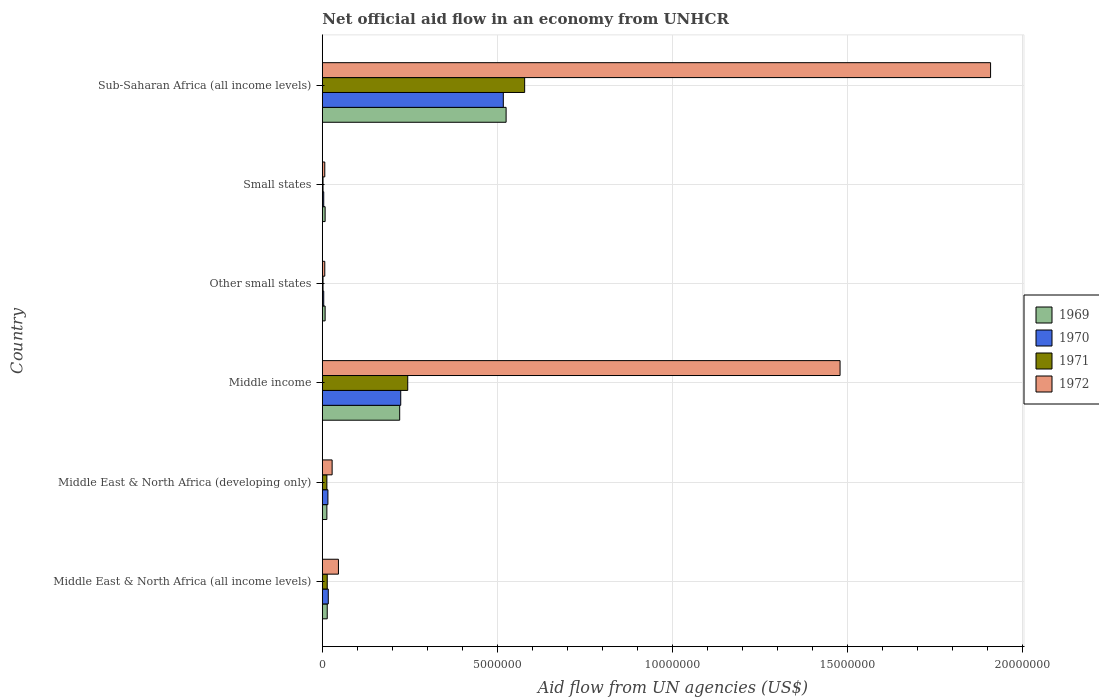How many different coloured bars are there?
Make the answer very short. 4. How many groups of bars are there?
Keep it short and to the point. 6. Are the number of bars per tick equal to the number of legend labels?
Ensure brevity in your answer.  Yes. Are the number of bars on each tick of the Y-axis equal?
Provide a succinct answer. Yes. How many bars are there on the 3rd tick from the top?
Your answer should be compact. 4. How many bars are there on the 2nd tick from the bottom?
Your answer should be very brief. 4. What is the label of the 3rd group of bars from the top?
Make the answer very short. Other small states. In how many cases, is the number of bars for a given country not equal to the number of legend labels?
Ensure brevity in your answer.  0. Across all countries, what is the maximum net official aid flow in 1970?
Provide a succinct answer. 5.17e+06. In which country was the net official aid flow in 1969 maximum?
Your answer should be compact. Sub-Saharan Africa (all income levels). In which country was the net official aid flow in 1970 minimum?
Keep it short and to the point. Other small states. What is the total net official aid flow in 1969 in the graph?
Offer a terse response. 7.89e+06. What is the difference between the net official aid flow in 1969 in Other small states and that in Sub-Saharan Africa (all income levels)?
Offer a very short reply. -5.17e+06. What is the difference between the net official aid flow in 1969 in Sub-Saharan Africa (all income levels) and the net official aid flow in 1971 in Middle income?
Offer a very short reply. 2.81e+06. What is the average net official aid flow in 1969 per country?
Ensure brevity in your answer.  1.32e+06. What is the difference between the net official aid flow in 1971 and net official aid flow in 1970 in Middle East & North Africa (developing only)?
Provide a short and direct response. -3.00e+04. What is the ratio of the net official aid flow in 1972 in Middle income to that in Other small states?
Offer a very short reply. 211.29. What is the difference between the highest and the second highest net official aid flow in 1970?
Your answer should be very brief. 2.93e+06. What is the difference between the highest and the lowest net official aid flow in 1972?
Keep it short and to the point. 1.90e+07. In how many countries, is the net official aid flow in 1971 greater than the average net official aid flow in 1971 taken over all countries?
Your answer should be very brief. 2. Is the sum of the net official aid flow in 1972 in Middle East & North Africa (developing only) and Middle income greater than the maximum net official aid flow in 1970 across all countries?
Provide a short and direct response. Yes. Is it the case that in every country, the sum of the net official aid flow in 1969 and net official aid flow in 1970 is greater than the sum of net official aid flow in 1972 and net official aid flow in 1971?
Offer a terse response. No. Is it the case that in every country, the sum of the net official aid flow in 1971 and net official aid flow in 1969 is greater than the net official aid flow in 1970?
Provide a succinct answer. Yes. What is the difference between two consecutive major ticks on the X-axis?
Keep it short and to the point. 5.00e+06. Where does the legend appear in the graph?
Keep it short and to the point. Center right. What is the title of the graph?
Your answer should be very brief. Net official aid flow in an economy from UNHCR. Does "1964" appear as one of the legend labels in the graph?
Provide a short and direct response. No. What is the label or title of the X-axis?
Provide a succinct answer. Aid flow from UN agencies (US$). What is the Aid flow from UN agencies (US$) of 1970 in Middle East & North Africa (all income levels)?
Provide a succinct answer. 1.70e+05. What is the Aid flow from UN agencies (US$) of 1972 in Middle East & North Africa (all income levels)?
Keep it short and to the point. 4.60e+05. What is the Aid flow from UN agencies (US$) of 1969 in Middle East & North Africa (developing only)?
Your answer should be compact. 1.30e+05. What is the Aid flow from UN agencies (US$) in 1972 in Middle East & North Africa (developing only)?
Your response must be concise. 2.80e+05. What is the Aid flow from UN agencies (US$) of 1969 in Middle income?
Provide a succinct answer. 2.21e+06. What is the Aid flow from UN agencies (US$) of 1970 in Middle income?
Ensure brevity in your answer.  2.24e+06. What is the Aid flow from UN agencies (US$) of 1971 in Middle income?
Your answer should be compact. 2.44e+06. What is the Aid flow from UN agencies (US$) in 1972 in Middle income?
Offer a very short reply. 1.48e+07. What is the Aid flow from UN agencies (US$) of 1969 in Other small states?
Make the answer very short. 8.00e+04. What is the Aid flow from UN agencies (US$) in 1970 in Other small states?
Your answer should be compact. 4.00e+04. What is the Aid flow from UN agencies (US$) in 1970 in Small states?
Provide a short and direct response. 4.00e+04. What is the Aid flow from UN agencies (US$) in 1969 in Sub-Saharan Africa (all income levels)?
Your answer should be compact. 5.25e+06. What is the Aid flow from UN agencies (US$) of 1970 in Sub-Saharan Africa (all income levels)?
Your response must be concise. 5.17e+06. What is the Aid flow from UN agencies (US$) of 1971 in Sub-Saharan Africa (all income levels)?
Ensure brevity in your answer.  5.78e+06. What is the Aid flow from UN agencies (US$) of 1972 in Sub-Saharan Africa (all income levels)?
Your response must be concise. 1.91e+07. Across all countries, what is the maximum Aid flow from UN agencies (US$) of 1969?
Your answer should be very brief. 5.25e+06. Across all countries, what is the maximum Aid flow from UN agencies (US$) in 1970?
Give a very brief answer. 5.17e+06. Across all countries, what is the maximum Aid flow from UN agencies (US$) in 1971?
Your response must be concise. 5.78e+06. Across all countries, what is the maximum Aid flow from UN agencies (US$) in 1972?
Your answer should be compact. 1.91e+07. Across all countries, what is the minimum Aid flow from UN agencies (US$) in 1970?
Keep it short and to the point. 4.00e+04. Across all countries, what is the minimum Aid flow from UN agencies (US$) in 1971?
Make the answer very short. 2.00e+04. What is the total Aid flow from UN agencies (US$) of 1969 in the graph?
Provide a succinct answer. 7.89e+06. What is the total Aid flow from UN agencies (US$) in 1970 in the graph?
Give a very brief answer. 7.82e+06. What is the total Aid flow from UN agencies (US$) of 1971 in the graph?
Your answer should be compact. 8.53e+06. What is the total Aid flow from UN agencies (US$) of 1972 in the graph?
Offer a terse response. 3.48e+07. What is the difference between the Aid flow from UN agencies (US$) in 1969 in Middle East & North Africa (all income levels) and that in Middle East & North Africa (developing only)?
Make the answer very short. 10000. What is the difference between the Aid flow from UN agencies (US$) of 1970 in Middle East & North Africa (all income levels) and that in Middle East & North Africa (developing only)?
Keep it short and to the point. 10000. What is the difference between the Aid flow from UN agencies (US$) in 1969 in Middle East & North Africa (all income levels) and that in Middle income?
Your response must be concise. -2.07e+06. What is the difference between the Aid flow from UN agencies (US$) of 1970 in Middle East & North Africa (all income levels) and that in Middle income?
Offer a terse response. -2.07e+06. What is the difference between the Aid flow from UN agencies (US$) in 1971 in Middle East & North Africa (all income levels) and that in Middle income?
Provide a succinct answer. -2.30e+06. What is the difference between the Aid flow from UN agencies (US$) in 1972 in Middle East & North Africa (all income levels) and that in Middle income?
Your answer should be very brief. -1.43e+07. What is the difference between the Aid flow from UN agencies (US$) in 1971 in Middle East & North Africa (all income levels) and that in Other small states?
Give a very brief answer. 1.20e+05. What is the difference between the Aid flow from UN agencies (US$) in 1972 in Middle East & North Africa (all income levels) and that in Other small states?
Make the answer very short. 3.90e+05. What is the difference between the Aid flow from UN agencies (US$) in 1969 in Middle East & North Africa (all income levels) and that in Small states?
Ensure brevity in your answer.  6.00e+04. What is the difference between the Aid flow from UN agencies (US$) of 1972 in Middle East & North Africa (all income levels) and that in Small states?
Give a very brief answer. 3.90e+05. What is the difference between the Aid flow from UN agencies (US$) of 1969 in Middle East & North Africa (all income levels) and that in Sub-Saharan Africa (all income levels)?
Offer a very short reply. -5.11e+06. What is the difference between the Aid flow from UN agencies (US$) of 1970 in Middle East & North Africa (all income levels) and that in Sub-Saharan Africa (all income levels)?
Ensure brevity in your answer.  -5.00e+06. What is the difference between the Aid flow from UN agencies (US$) of 1971 in Middle East & North Africa (all income levels) and that in Sub-Saharan Africa (all income levels)?
Your answer should be very brief. -5.64e+06. What is the difference between the Aid flow from UN agencies (US$) of 1972 in Middle East & North Africa (all income levels) and that in Sub-Saharan Africa (all income levels)?
Your answer should be very brief. -1.86e+07. What is the difference between the Aid flow from UN agencies (US$) of 1969 in Middle East & North Africa (developing only) and that in Middle income?
Your answer should be compact. -2.08e+06. What is the difference between the Aid flow from UN agencies (US$) of 1970 in Middle East & North Africa (developing only) and that in Middle income?
Give a very brief answer. -2.08e+06. What is the difference between the Aid flow from UN agencies (US$) of 1971 in Middle East & North Africa (developing only) and that in Middle income?
Give a very brief answer. -2.31e+06. What is the difference between the Aid flow from UN agencies (US$) in 1972 in Middle East & North Africa (developing only) and that in Middle income?
Offer a terse response. -1.45e+07. What is the difference between the Aid flow from UN agencies (US$) of 1969 in Middle East & North Africa (developing only) and that in Other small states?
Your response must be concise. 5.00e+04. What is the difference between the Aid flow from UN agencies (US$) of 1970 in Middle East & North Africa (developing only) and that in Other small states?
Keep it short and to the point. 1.20e+05. What is the difference between the Aid flow from UN agencies (US$) in 1971 in Middle East & North Africa (developing only) and that in Other small states?
Make the answer very short. 1.10e+05. What is the difference between the Aid flow from UN agencies (US$) in 1969 in Middle East & North Africa (developing only) and that in Sub-Saharan Africa (all income levels)?
Provide a succinct answer. -5.12e+06. What is the difference between the Aid flow from UN agencies (US$) in 1970 in Middle East & North Africa (developing only) and that in Sub-Saharan Africa (all income levels)?
Your answer should be very brief. -5.01e+06. What is the difference between the Aid flow from UN agencies (US$) of 1971 in Middle East & North Africa (developing only) and that in Sub-Saharan Africa (all income levels)?
Offer a very short reply. -5.65e+06. What is the difference between the Aid flow from UN agencies (US$) in 1972 in Middle East & North Africa (developing only) and that in Sub-Saharan Africa (all income levels)?
Ensure brevity in your answer.  -1.88e+07. What is the difference between the Aid flow from UN agencies (US$) of 1969 in Middle income and that in Other small states?
Give a very brief answer. 2.13e+06. What is the difference between the Aid flow from UN agencies (US$) of 1970 in Middle income and that in Other small states?
Your answer should be compact. 2.20e+06. What is the difference between the Aid flow from UN agencies (US$) in 1971 in Middle income and that in Other small states?
Give a very brief answer. 2.42e+06. What is the difference between the Aid flow from UN agencies (US$) of 1972 in Middle income and that in Other small states?
Your answer should be compact. 1.47e+07. What is the difference between the Aid flow from UN agencies (US$) of 1969 in Middle income and that in Small states?
Keep it short and to the point. 2.13e+06. What is the difference between the Aid flow from UN agencies (US$) of 1970 in Middle income and that in Small states?
Offer a terse response. 2.20e+06. What is the difference between the Aid flow from UN agencies (US$) in 1971 in Middle income and that in Small states?
Offer a very short reply. 2.42e+06. What is the difference between the Aid flow from UN agencies (US$) in 1972 in Middle income and that in Small states?
Ensure brevity in your answer.  1.47e+07. What is the difference between the Aid flow from UN agencies (US$) of 1969 in Middle income and that in Sub-Saharan Africa (all income levels)?
Provide a short and direct response. -3.04e+06. What is the difference between the Aid flow from UN agencies (US$) in 1970 in Middle income and that in Sub-Saharan Africa (all income levels)?
Keep it short and to the point. -2.93e+06. What is the difference between the Aid flow from UN agencies (US$) in 1971 in Middle income and that in Sub-Saharan Africa (all income levels)?
Your response must be concise. -3.34e+06. What is the difference between the Aid flow from UN agencies (US$) of 1972 in Middle income and that in Sub-Saharan Africa (all income levels)?
Make the answer very short. -4.30e+06. What is the difference between the Aid flow from UN agencies (US$) in 1969 in Other small states and that in Small states?
Give a very brief answer. 0. What is the difference between the Aid flow from UN agencies (US$) in 1972 in Other small states and that in Small states?
Your answer should be compact. 0. What is the difference between the Aid flow from UN agencies (US$) of 1969 in Other small states and that in Sub-Saharan Africa (all income levels)?
Give a very brief answer. -5.17e+06. What is the difference between the Aid flow from UN agencies (US$) in 1970 in Other small states and that in Sub-Saharan Africa (all income levels)?
Offer a very short reply. -5.13e+06. What is the difference between the Aid flow from UN agencies (US$) in 1971 in Other small states and that in Sub-Saharan Africa (all income levels)?
Your answer should be compact. -5.76e+06. What is the difference between the Aid flow from UN agencies (US$) in 1972 in Other small states and that in Sub-Saharan Africa (all income levels)?
Keep it short and to the point. -1.90e+07. What is the difference between the Aid flow from UN agencies (US$) in 1969 in Small states and that in Sub-Saharan Africa (all income levels)?
Give a very brief answer. -5.17e+06. What is the difference between the Aid flow from UN agencies (US$) of 1970 in Small states and that in Sub-Saharan Africa (all income levels)?
Ensure brevity in your answer.  -5.13e+06. What is the difference between the Aid flow from UN agencies (US$) of 1971 in Small states and that in Sub-Saharan Africa (all income levels)?
Offer a terse response. -5.76e+06. What is the difference between the Aid flow from UN agencies (US$) in 1972 in Small states and that in Sub-Saharan Africa (all income levels)?
Offer a terse response. -1.90e+07. What is the difference between the Aid flow from UN agencies (US$) in 1969 in Middle East & North Africa (all income levels) and the Aid flow from UN agencies (US$) in 1970 in Middle East & North Africa (developing only)?
Your response must be concise. -2.00e+04. What is the difference between the Aid flow from UN agencies (US$) in 1969 in Middle East & North Africa (all income levels) and the Aid flow from UN agencies (US$) in 1971 in Middle East & North Africa (developing only)?
Give a very brief answer. 10000. What is the difference between the Aid flow from UN agencies (US$) in 1969 in Middle East & North Africa (all income levels) and the Aid flow from UN agencies (US$) in 1972 in Middle East & North Africa (developing only)?
Ensure brevity in your answer.  -1.40e+05. What is the difference between the Aid flow from UN agencies (US$) of 1971 in Middle East & North Africa (all income levels) and the Aid flow from UN agencies (US$) of 1972 in Middle East & North Africa (developing only)?
Provide a short and direct response. -1.40e+05. What is the difference between the Aid flow from UN agencies (US$) of 1969 in Middle East & North Africa (all income levels) and the Aid flow from UN agencies (US$) of 1970 in Middle income?
Your answer should be compact. -2.10e+06. What is the difference between the Aid flow from UN agencies (US$) in 1969 in Middle East & North Africa (all income levels) and the Aid flow from UN agencies (US$) in 1971 in Middle income?
Your response must be concise. -2.30e+06. What is the difference between the Aid flow from UN agencies (US$) of 1969 in Middle East & North Africa (all income levels) and the Aid flow from UN agencies (US$) of 1972 in Middle income?
Ensure brevity in your answer.  -1.46e+07. What is the difference between the Aid flow from UN agencies (US$) in 1970 in Middle East & North Africa (all income levels) and the Aid flow from UN agencies (US$) in 1971 in Middle income?
Your answer should be very brief. -2.27e+06. What is the difference between the Aid flow from UN agencies (US$) in 1970 in Middle East & North Africa (all income levels) and the Aid flow from UN agencies (US$) in 1972 in Middle income?
Offer a very short reply. -1.46e+07. What is the difference between the Aid flow from UN agencies (US$) of 1971 in Middle East & North Africa (all income levels) and the Aid flow from UN agencies (US$) of 1972 in Middle income?
Offer a very short reply. -1.46e+07. What is the difference between the Aid flow from UN agencies (US$) in 1969 in Middle East & North Africa (all income levels) and the Aid flow from UN agencies (US$) in 1970 in Other small states?
Ensure brevity in your answer.  1.00e+05. What is the difference between the Aid flow from UN agencies (US$) of 1969 in Middle East & North Africa (all income levels) and the Aid flow from UN agencies (US$) of 1972 in Other small states?
Provide a succinct answer. 7.00e+04. What is the difference between the Aid flow from UN agencies (US$) of 1970 in Middle East & North Africa (all income levels) and the Aid flow from UN agencies (US$) of 1971 in Other small states?
Offer a very short reply. 1.50e+05. What is the difference between the Aid flow from UN agencies (US$) in 1969 in Middle East & North Africa (all income levels) and the Aid flow from UN agencies (US$) in 1970 in Small states?
Your answer should be compact. 1.00e+05. What is the difference between the Aid flow from UN agencies (US$) of 1970 in Middle East & North Africa (all income levels) and the Aid flow from UN agencies (US$) of 1971 in Small states?
Your answer should be compact. 1.50e+05. What is the difference between the Aid flow from UN agencies (US$) of 1970 in Middle East & North Africa (all income levels) and the Aid flow from UN agencies (US$) of 1972 in Small states?
Make the answer very short. 1.00e+05. What is the difference between the Aid flow from UN agencies (US$) of 1969 in Middle East & North Africa (all income levels) and the Aid flow from UN agencies (US$) of 1970 in Sub-Saharan Africa (all income levels)?
Ensure brevity in your answer.  -5.03e+06. What is the difference between the Aid flow from UN agencies (US$) of 1969 in Middle East & North Africa (all income levels) and the Aid flow from UN agencies (US$) of 1971 in Sub-Saharan Africa (all income levels)?
Provide a succinct answer. -5.64e+06. What is the difference between the Aid flow from UN agencies (US$) of 1969 in Middle East & North Africa (all income levels) and the Aid flow from UN agencies (US$) of 1972 in Sub-Saharan Africa (all income levels)?
Offer a very short reply. -1.90e+07. What is the difference between the Aid flow from UN agencies (US$) of 1970 in Middle East & North Africa (all income levels) and the Aid flow from UN agencies (US$) of 1971 in Sub-Saharan Africa (all income levels)?
Provide a succinct answer. -5.61e+06. What is the difference between the Aid flow from UN agencies (US$) of 1970 in Middle East & North Africa (all income levels) and the Aid flow from UN agencies (US$) of 1972 in Sub-Saharan Africa (all income levels)?
Give a very brief answer. -1.89e+07. What is the difference between the Aid flow from UN agencies (US$) in 1971 in Middle East & North Africa (all income levels) and the Aid flow from UN agencies (US$) in 1972 in Sub-Saharan Africa (all income levels)?
Offer a terse response. -1.90e+07. What is the difference between the Aid flow from UN agencies (US$) in 1969 in Middle East & North Africa (developing only) and the Aid flow from UN agencies (US$) in 1970 in Middle income?
Keep it short and to the point. -2.11e+06. What is the difference between the Aid flow from UN agencies (US$) of 1969 in Middle East & North Africa (developing only) and the Aid flow from UN agencies (US$) of 1971 in Middle income?
Make the answer very short. -2.31e+06. What is the difference between the Aid flow from UN agencies (US$) of 1969 in Middle East & North Africa (developing only) and the Aid flow from UN agencies (US$) of 1972 in Middle income?
Keep it short and to the point. -1.47e+07. What is the difference between the Aid flow from UN agencies (US$) of 1970 in Middle East & North Africa (developing only) and the Aid flow from UN agencies (US$) of 1971 in Middle income?
Your answer should be compact. -2.28e+06. What is the difference between the Aid flow from UN agencies (US$) in 1970 in Middle East & North Africa (developing only) and the Aid flow from UN agencies (US$) in 1972 in Middle income?
Your response must be concise. -1.46e+07. What is the difference between the Aid flow from UN agencies (US$) of 1971 in Middle East & North Africa (developing only) and the Aid flow from UN agencies (US$) of 1972 in Middle income?
Your answer should be compact. -1.47e+07. What is the difference between the Aid flow from UN agencies (US$) of 1969 in Middle East & North Africa (developing only) and the Aid flow from UN agencies (US$) of 1971 in Other small states?
Give a very brief answer. 1.10e+05. What is the difference between the Aid flow from UN agencies (US$) of 1970 in Middle East & North Africa (developing only) and the Aid flow from UN agencies (US$) of 1971 in Other small states?
Provide a short and direct response. 1.40e+05. What is the difference between the Aid flow from UN agencies (US$) in 1969 in Middle East & North Africa (developing only) and the Aid flow from UN agencies (US$) in 1971 in Small states?
Keep it short and to the point. 1.10e+05. What is the difference between the Aid flow from UN agencies (US$) of 1969 in Middle East & North Africa (developing only) and the Aid flow from UN agencies (US$) of 1970 in Sub-Saharan Africa (all income levels)?
Provide a succinct answer. -5.04e+06. What is the difference between the Aid flow from UN agencies (US$) of 1969 in Middle East & North Africa (developing only) and the Aid flow from UN agencies (US$) of 1971 in Sub-Saharan Africa (all income levels)?
Make the answer very short. -5.65e+06. What is the difference between the Aid flow from UN agencies (US$) in 1969 in Middle East & North Africa (developing only) and the Aid flow from UN agencies (US$) in 1972 in Sub-Saharan Africa (all income levels)?
Ensure brevity in your answer.  -1.90e+07. What is the difference between the Aid flow from UN agencies (US$) in 1970 in Middle East & North Africa (developing only) and the Aid flow from UN agencies (US$) in 1971 in Sub-Saharan Africa (all income levels)?
Provide a short and direct response. -5.62e+06. What is the difference between the Aid flow from UN agencies (US$) of 1970 in Middle East & North Africa (developing only) and the Aid flow from UN agencies (US$) of 1972 in Sub-Saharan Africa (all income levels)?
Your response must be concise. -1.89e+07. What is the difference between the Aid flow from UN agencies (US$) of 1971 in Middle East & North Africa (developing only) and the Aid flow from UN agencies (US$) of 1972 in Sub-Saharan Africa (all income levels)?
Make the answer very short. -1.90e+07. What is the difference between the Aid flow from UN agencies (US$) of 1969 in Middle income and the Aid flow from UN agencies (US$) of 1970 in Other small states?
Give a very brief answer. 2.17e+06. What is the difference between the Aid flow from UN agencies (US$) in 1969 in Middle income and the Aid flow from UN agencies (US$) in 1971 in Other small states?
Give a very brief answer. 2.19e+06. What is the difference between the Aid flow from UN agencies (US$) of 1969 in Middle income and the Aid flow from UN agencies (US$) of 1972 in Other small states?
Keep it short and to the point. 2.14e+06. What is the difference between the Aid flow from UN agencies (US$) in 1970 in Middle income and the Aid flow from UN agencies (US$) in 1971 in Other small states?
Offer a very short reply. 2.22e+06. What is the difference between the Aid flow from UN agencies (US$) of 1970 in Middle income and the Aid flow from UN agencies (US$) of 1972 in Other small states?
Your answer should be very brief. 2.17e+06. What is the difference between the Aid flow from UN agencies (US$) in 1971 in Middle income and the Aid flow from UN agencies (US$) in 1972 in Other small states?
Provide a short and direct response. 2.37e+06. What is the difference between the Aid flow from UN agencies (US$) of 1969 in Middle income and the Aid flow from UN agencies (US$) of 1970 in Small states?
Make the answer very short. 2.17e+06. What is the difference between the Aid flow from UN agencies (US$) in 1969 in Middle income and the Aid flow from UN agencies (US$) in 1971 in Small states?
Give a very brief answer. 2.19e+06. What is the difference between the Aid flow from UN agencies (US$) of 1969 in Middle income and the Aid flow from UN agencies (US$) of 1972 in Small states?
Ensure brevity in your answer.  2.14e+06. What is the difference between the Aid flow from UN agencies (US$) in 1970 in Middle income and the Aid flow from UN agencies (US$) in 1971 in Small states?
Your response must be concise. 2.22e+06. What is the difference between the Aid flow from UN agencies (US$) of 1970 in Middle income and the Aid flow from UN agencies (US$) of 1972 in Small states?
Provide a short and direct response. 2.17e+06. What is the difference between the Aid flow from UN agencies (US$) in 1971 in Middle income and the Aid flow from UN agencies (US$) in 1972 in Small states?
Your answer should be very brief. 2.37e+06. What is the difference between the Aid flow from UN agencies (US$) of 1969 in Middle income and the Aid flow from UN agencies (US$) of 1970 in Sub-Saharan Africa (all income levels)?
Make the answer very short. -2.96e+06. What is the difference between the Aid flow from UN agencies (US$) in 1969 in Middle income and the Aid flow from UN agencies (US$) in 1971 in Sub-Saharan Africa (all income levels)?
Your answer should be very brief. -3.57e+06. What is the difference between the Aid flow from UN agencies (US$) in 1969 in Middle income and the Aid flow from UN agencies (US$) in 1972 in Sub-Saharan Africa (all income levels)?
Ensure brevity in your answer.  -1.69e+07. What is the difference between the Aid flow from UN agencies (US$) in 1970 in Middle income and the Aid flow from UN agencies (US$) in 1971 in Sub-Saharan Africa (all income levels)?
Give a very brief answer. -3.54e+06. What is the difference between the Aid flow from UN agencies (US$) of 1970 in Middle income and the Aid flow from UN agencies (US$) of 1972 in Sub-Saharan Africa (all income levels)?
Ensure brevity in your answer.  -1.68e+07. What is the difference between the Aid flow from UN agencies (US$) of 1971 in Middle income and the Aid flow from UN agencies (US$) of 1972 in Sub-Saharan Africa (all income levels)?
Your answer should be compact. -1.66e+07. What is the difference between the Aid flow from UN agencies (US$) in 1969 in Other small states and the Aid flow from UN agencies (US$) in 1971 in Small states?
Give a very brief answer. 6.00e+04. What is the difference between the Aid flow from UN agencies (US$) of 1970 in Other small states and the Aid flow from UN agencies (US$) of 1971 in Small states?
Ensure brevity in your answer.  2.00e+04. What is the difference between the Aid flow from UN agencies (US$) of 1969 in Other small states and the Aid flow from UN agencies (US$) of 1970 in Sub-Saharan Africa (all income levels)?
Offer a terse response. -5.09e+06. What is the difference between the Aid flow from UN agencies (US$) in 1969 in Other small states and the Aid flow from UN agencies (US$) in 1971 in Sub-Saharan Africa (all income levels)?
Ensure brevity in your answer.  -5.70e+06. What is the difference between the Aid flow from UN agencies (US$) in 1969 in Other small states and the Aid flow from UN agencies (US$) in 1972 in Sub-Saharan Africa (all income levels)?
Keep it short and to the point. -1.90e+07. What is the difference between the Aid flow from UN agencies (US$) in 1970 in Other small states and the Aid flow from UN agencies (US$) in 1971 in Sub-Saharan Africa (all income levels)?
Ensure brevity in your answer.  -5.74e+06. What is the difference between the Aid flow from UN agencies (US$) of 1970 in Other small states and the Aid flow from UN agencies (US$) of 1972 in Sub-Saharan Africa (all income levels)?
Offer a very short reply. -1.90e+07. What is the difference between the Aid flow from UN agencies (US$) of 1971 in Other small states and the Aid flow from UN agencies (US$) of 1972 in Sub-Saharan Africa (all income levels)?
Give a very brief answer. -1.91e+07. What is the difference between the Aid flow from UN agencies (US$) in 1969 in Small states and the Aid flow from UN agencies (US$) in 1970 in Sub-Saharan Africa (all income levels)?
Provide a short and direct response. -5.09e+06. What is the difference between the Aid flow from UN agencies (US$) of 1969 in Small states and the Aid flow from UN agencies (US$) of 1971 in Sub-Saharan Africa (all income levels)?
Offer a very short reply. -5.70e+06. What is the difference between the Aid flow from UN agencies (US$) in 1969 in Small states and the Aid flow from UN agencies (US$) in 1972 in Sub-Saharan Africa (all income levels)?
Offer a terse response. -1.90e+07. What is the difference between the Aid flow from UN agencies (US$) in 1970 in Small states and the Aid flow from UN agencies (US$) in 1971 in Sub-Saharan Africa (all income levels)?
Make the answer very short. -5.74e+06. What is the difference between the Aid flow from UN agencies (US$) of 1970 in Small states and the Aid flow from UN agencies (US$) of 1972 in Sub-Saharan Africa (all income levels)?
Provide a short and direct response. -1.90e+07. What is the difference between the Aid flow from UN agencies (US$) in 1971 in Small states and the Aid flow from UN agencies (US$) in 1972 in Sub-Saharan Africa (all income levels)?
Keep it short and to the point. -1.91e+07. What is the average Aid flow from UN agencies (US$) in 1969 per country?
Make the answer very short. 1.32e+06. What is the average Aid flow from UN agencies (US$) of 1970 per country?
Your answer should be compact. 1.30e+06. What is the average Aid flow from UN agencies (US$) of 1971 per country?
Keep it short and to the point. 1.42e+06. What is the average Aid flow from UN agencies (US$) of 1972 per country?
Offer a terse response. 5.79e+06. What is the difference between the Aid flow from UN agencies (US$) of 1969 and Aid flow from UN agencies (US$) of 1971 in Middle East & North Africa (all income levels)?
Your answer should be compact. 0. What is the difference between the Aid flow from UN agencies (US$) of 1969 and Aid flow from UN agencies (US$) of 1972 in Middle East & North Africa (all income levels)?
Offer a very short reply. -3.20e+05. What is the difference between the Aid flow from UN agencies (US$) of 1970 and Aid flow from UN agencies (US$) of 1971 in Middle East & North Africa (all income levels)?
Provide a short and direct response. 3.00e+04. What is the difference between the Aid flow from UN agencies (US$) of 1971 and Aid flow from UN agencies (US$) of 1972 in Middle East & North Africa (all income levels)?
Offer a terse response. -3.20e+05. What is the difference between the Aid flow from UN agencies (US$) of 1969 and Aid flow from UN agencies (US$) of 1970 in Middle East & North Africa (developing only)?
Keep it short and to the point. -3.00e+04. What is the difference between the Aid flow from UN agencies (US$) in 1969 and Aid flow from UN agencies (US$) in 1971 in Middle East & North Africa (developing only)?
Offer a terse response. 0. What is the difference between the Aid flow from UN agencies (US$) in 1969 and Aid flow from UN agencies (US$) in 1972 in Middle East & North Africa (developing only)?
Your answer should be compact. -1.50e+05. What is the difference between the Aid flow from UN agencies (US$) in 1971 and Aid flow from UN agencies (US$) in 1972 in Middle East & North Africa (developing only)?
Offer a very short reply. -1.50e+05. What is the difference between the Aid flow from UN agencies (US$) in 1969 and Aid flow from UN agencies (US$) in 1971 in Middle income?
Make the answer very short. -2.30e+05. What is the difference between the Aid flow from UN agencies (US$) of 1969 and Aid flow from UN agencies (US$) of 1972 in Middle income?
Your response must be concise. -1.26e+07. What is the difference between the Aid flow from UN agencies (US$) in 1970 and Aid flow from UN agencies (US$) in 1971 in Middle income?
Your answer should be very brief. -2.00e+05. What is the difference between the Aid flow from UN agencies (US$) in 1970 and Aid flow from UN agencies (US$) in 1972 in Middle income?
Provide a succinct answer. -1.26e+07. What is the difference between the Aid flow from UN agencies (US$) in 1971 and Aid flow from UN agencies (US$) in 1972 in Middle income?
Give a very brief answer. -1.24e+07. What is the difference between the Aid flow from UN agencies (US$) of 1969 and Aid flow from UN agencies (US$) of 1970 in Other small states?
Your response must be concise. 4.00e+04. What is the difference between the Aid flow from UN agencies (US$) of 1969 and Aid flow from UN agencies (US$) of 1971 in Other small states?
Provide a short and direct response. 6.00e+04. What is the difference between the Aid flow from UN agencies (US$) of 1971 and Aid flow from UN agencies (US$) of 1972 in Other small states?
Your answer should be very brief. -5.00e+04. What is the difference between the Aid flow from UN agencies (US$) of 1969 and Aid flow from UN agencies (US$) of 1972 in Small states?
Your response must be concise. 10000. What is the difference between the Aid flow from UN agencies (US$) of 1970 and Aid flow from UN agencies (US$) of 1971 in Small states?
Your response must be concise. 2.00e+04. What is the difference between the Aid flow from UN agencies (US$) of 1971 and Aid flow from UN agencies (US$) of 1972 in Small states?
Provide a succinct answer. -5.00e+04. What is the difference between the Aid flow from UN agencies (US$) of 1969 and Aid flow from UN agencies (US$) of 1971 in Sub-Saharan Africa (all income levels)?
Make the answer very short. -5.30e+05. What is the difference between the Aid flow from UN agencies (US$) of 1969 and Aid flow from UN agencies (US$) of 1972 in Sub-Saharan Africa (all income levels)?
Offer a very short reply. -1.38e+07. What is the difference between the Aid flow from UN agencies (US$) of 1970 and Aid flow from UN agencies (US$) of 1971 in Sub-Saharan Africa (all income levels)?
Make the answer very short. -6.10e+05. What is the difference between the Aid flow from UN agencies (US$) of 1970 and Aid flow from UN agencies (US$) of 1972 in Sub-Saharan Africa (all income levels)?
Keep it short and to the point. -1.39e+07. What is the difference between the Aid flow from UN agencies (US$) in 1971 and Aid flow from UN agencies (US$) in 1972 in Sub-Saharan Africa (all income levels)?
Your response must be concise. -1.33e+07. What is the ratio of the Aid flow from UN agencies (US$) of 1970 in Middle East & North Africa (all income levels) to that in Middle East & North Africa (developing only)?
Make the answer very short. 1.06. What is the ratio of the Aid flow from UN agencies (US$) in 1971 in Middle East & North Africa (all income levels) to that in Middle East & North Africa (developing only)?
Offer a terse response. 1.08. What is the ratio of the Aid flow from UN agencies (US$) in 1972 in Middle East & North Africa (all income levels) to that in Middle East & North Africa (developing only)?
Give a very brief answer. 1.64. What is the ratio of the Aid flow from UN agencies (US$) of 1969 in Middle East & North Africa (all income levels) to that in Middle income?
Your answer should be very brief. 0.06. What is the ratio of the Aid flow from UN agencies (US$) of 1970 in Middle East & North Africa (all income levels) to that in Middle income?
Your response must be concise. 0.08. What is the ratio of the Aid flow from UN agencies (US$) in 1971 in Middle East & North Africa (all income levels) to that in Middle income?
Provide a short and direct response. 0.06. What is the ratio of the Aid flow from UN agencies (US$) in 1972 in Middle East & North Africa (all income levels) to that in Middle income?
Your response must be concise. 0.03. What is the ratio of the Aid flow from UN agencies (US$) in 1970 in Middle East & North Africa (all income levels) to that in Other small states?
Keep it short and to the point. 4.25. What is the ratio of the Aid flow from UN agencies (US$) of 1972 in Middle East & North Africa (all income levels) to that in Other small states?
Offer a very short reply. 6.57. What is the ratio of the Aid flow from UN agencies (US$) of 1969 in Middle East & North Africa (all income levels) to that in Small states?
Make the answer very short. 1.75. What is the ratio of the Aid flow from UN agencies (US$) in 1970 in Middle East & North Africa (all income levels) to that in Small states?
Keep it short and to the point. 4.25. What is the ratio of the Aid flow from UN agencies (US$) in 1971 in Middle East & North Africa (all income levels) to that in Small states?
Your response must be concise. 7. What is the ratio of the Aid flow from UN agencies (US$) in 1972 in Middle East & North Africa (all income levels) to that in Small states?
Ensure brevity in your answer.  6.57. What is the ratio of the Aid flow from UN agencies (US$) of 1969 in Middle East & North Africa (all income levels) to that in Sub-Saharan Africa (all income levels)?
Ensure brevity in your answer.  0.03. What is the ratio of the Aid flow from UN agencies (US$) of 1970 in Middle East & North Africa (all income levels) to that in Sub-Saharan Africa (all income levels)?
Your answer should be compact. 0.03. What is the ratio of the Aid flow from UN agencies (US$) of 1971 in Middle East & North Africa (all income levels) to that in Sub-Saharan Africa (all income levels)?
Offer a very short reply. 0.02. What is the ratio of the Aid flow from UN agencies (US$) in 1972 in Middle East & North Africa (all income levels) to that in Sub-Saharan Africa (all income levels)?
Make the answer very short. 0.02. What is the ratio of the Aid flow from UN agencies (US$) in 1969 in Middle East & North Africa (developing only) to that in Middle income?
Your answer should be compact. 0.06. What is the ratio of the Aid flow from UN agencies (US$) in 1970 in Middle East & North Africa (developing only) to that in Middle income?
Make the answer very short. 0.07. What is the ratio of the Aid flow from UN agencies (US$) of 1971 in Middle East & North Africa (developing only) to that in Middle income?
Provide a short and direct response. 0.05. What is the ratio of the Aid flow from UN agencies (US$) in 1972 in Middle East & North Africa (developing only) to that in Middle income?
Keep it short and to the point. 0.02. What is the ratio of the Aid flow from UN agencies (US$) in 1969 in Middle East & North Africa (developing only) to that in Other small states?
Give a very brief answer. 1.62. What is the ratio of the Aid flow from UN agencies (US$) in 1970 in Middle East & North Africa (developing only) to that in Other small states?
Provide a short and direct response. 4. What is the ratio of the Aid flow from UN agencies (US$) in 1971 in Middle East & North Africa (developing only) to that in Other small states?
Your answer should be compact. 6.5. What is the ratio of the Aid flow from UN agencies (US$) in 1969 in Middle East & North Africa (developing only) to that in Small states?
Your answer should be very brief. 1.62. What is the ratio of the Aid flow from UN agencies (US$) of 1970 in Middle East & North Africa (developing only) to that in Small states?
Your answer should be very brief. 4. What is the ratio of the Aid flow from UN agencies (US$) of 1969 in Middle East & North Africa (developing only) to that in Sub-Saharan Africa (all income levels)?
Ensure brevity in your answer.  0.02. What is the ratio of the Aid flow from UN agencies (US$) in 1970 in Middle East & North Africa (developing only) to that in Sub-Saharan Africa (all income levels)?
Make the answer very short. 0.03. What is the ratio of the Aid flow from UN agencies (US$) of 1971 in Middle East & North Africa (developing only) to that in Sub-Saharan Africa (all income levels)?
Your response must be concise. 0.02. What is the ratio of the Aid flow from UN agencies (US$) of 1972 in Middle East & North Africa (developing only) to that in Sub-Saharan Africa (all income levels)?
Your response must be concise. 0.01. What is the ratio of the Aid flow from UN agencies (US$) in 1969 in Middle income to that in Other small states?
Offer a terse response. 27.62. What is the ratio of the Aid flow from UN agencies (US$) in 1971 in Middle income to that in Other small states?
Make the answer very short. 122. What is the ratio of the Aid flow from UN agencies (US$) of 1972 in Middle income to that in Other small states?
Keep it short and to the point. 211.29. What is the ratio of the Aid flow from UN agencies (US$) of 1969 in Middle income to that in Small states?
Ensure brevity in your answer.  27.62. What is the ratio of the Aid flow from UN agencies (US$) in 1970 in Middle income to that in Small states?
Make the answer very short. 56. What is the ratio of the Aid flow from UN agencies (US$) in 1971 in Middle income to that in Small states?
Your response must be concise. 122. What is the ratio of the Aid flow from UN agencies (US$) of 1972 in Middle income to that in Small states?
Provide a succinct answer. 211.29. What is the ratio of the Aid flow from UN agencies (US$) of 1969 in Middle income to that in Sub-Saharan Africa (all income levels)?
Offer a terse response. 0.42. What is the ratio of the Aid flow from UN agencies (US$) of 1970 in Middle income to that in Sub-Saharan Africa (all income levels)?
Provide a succinct answer. 0.43. What is the ratio of the Aid flow from UN agencies (US$) of 1971 in Middle income to that in Sub-Saharan Africa (all income levels)?
Offer a very short reply. 0.42. What is the ratio of the Aid flow from UN agencies (US$) of 1972 in Middle income to that in Sub-Saharan Africa (all income levels)?
Provide a succinct answer. 0.77. What is the ratio of the Aid flow from UN agencies (US$) of 1969 in Other small states to that in Small states?
Provide a short and direct response. 1. What is the ratio of the Aid flow from UN agencies (US$) in 1970 in Other small states to that in Small states?
Your response must be concise. 1. What is the ratio of the Aid flow from UN agencies (US$) of 1972 in Other small states to that in Small states?
Keep it short and to the point. 1. What is the ratio of the Aid flow from UN agencies (US$) in 1969 in Other small states to that in Sub-Saharan Africa (all income levels)?
Provide a succinct answer. 0.02. What is the ratio of the Aid flow from UN agencies (US$) of 1970 in Other small states to that in Sub-Saharan Africa (all income levels)?
Your answer should be compact. 0.01. What is the ratio of the Aid flow from UN agencies (US$) of 1971 in Other small states to that in Sub-Saharan Africa (all income levels)?
Provide a short and direct response. 0. What is the ratio of the Aid flow from UN agencies (US$) of 1972 in Other small states to that in Sub-Saharan Africa (all income levels)?
Provide a succinct answer. 0. What is the ratio of the Aid flow from UN agencies (US$) in 1969 in Small states to that in Sub-Saharan Africa (all income levels)?
Give a very brief answer. 0.02. What is the ratio of the Aid flow from UN agencies (US$) of 1970 in Small states to that in Sub-Saharan Africa (all income levels)?
Offer a terse response. 0.01. What is the ratio of the Aid flow from UN agencies (US$) of 1971 in Small states to that in Sub-Saharan Africa (all income levels)?
Your response must be concise. 0. What is the ratio of the Aid flow from UN agencies (US$) of 1972 in Small states to that in Sub-Saharan Africa (all income levels)?
Provide a short and direct response. 0. What is the difference between the highest and the second highest Aid flow from UN agencies (US$) of 1969?
Your response must be concise. 3.04e+06. What is the difference between the highest and the second highest Aid flow from UN agencies (US$) in 1970?
Ensure brevity in your answer.  2.93e+06. What is the difference between the highest and the second highest Aid flow from UN agencies (US$) of 1971?
Provide a short and direct response. 3.34e+06. What is the difference between the highest and the second highest Aid flow from UN agencies (US$) of 1972?
Your response must be concise. 4.30e+06. What is the difference between the highest and the lowest Aid flow from UN agencies (US$) of 1969?
Make the answer very short. 5.17e+06. What is the difference between the highest and the lowest Aid flow from UN agencies (US$) of 1970?
Provide a short and direct response. 5.13e+06. What is the difference between the highest and the lowest Aid flow from UN agencies (US$) in 1971?
Your answer should be very brief. 5.76e+06. What is the difference between the highest and the lowest Aid flow from UN agencies (US$) in 1972?
Provide a succinct answer. 1.90e+07. 